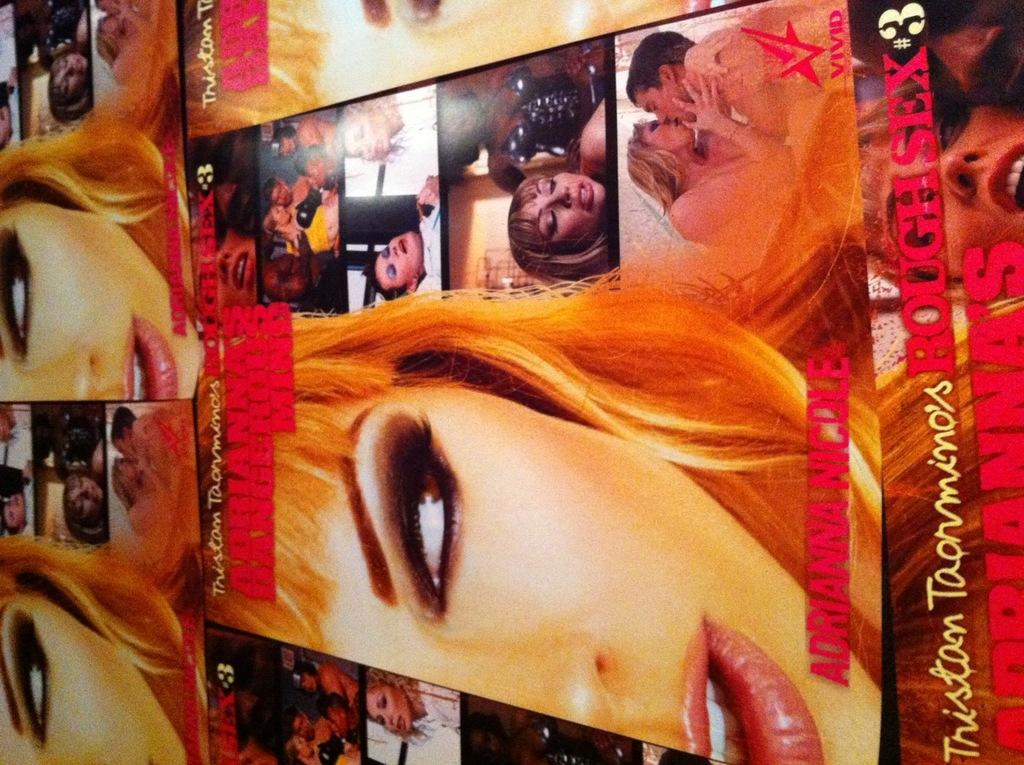<image>
Relay a brief, clear account of the picture shown. Posters on a wall that has a number 3 on the bottom right. 